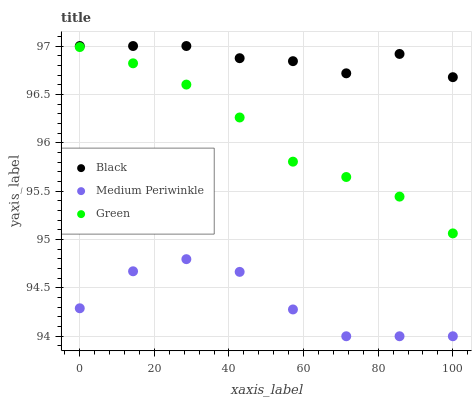Does Medium Periwinkle have the minimum area under the curve?
Answer yes or no. Yes. Does Black have the maximum area under the curve?
Answer yes or no. Yes. Does Green have the minimum area under the curve?
Answer yes or no. No. Does Green have the maximum area under the curve?
Answer yes or no. No. Is Green the smoothest?
Answer yes or no. Yes. Is Medium Periwinkle the roughest?
Answer yes or no. Yes. Is Black the smoothest?
Answer yes or no. No. Is Black the roughest?
Answer yes or no. No. Does Medium Periwinkle have the lowest value?
Answer yes or no. Yes. Does Green have the lowest value?
Answer yes or no. No. Does Black have the highest value?
Answer yes or no. Yes. Does Green have the highest value?
Answer yes or no. No. Is Medium Periwinkle less than Black?
Answer yes or no. Yes. Is Black greater than Medium Periwinkle?
Answer yes or no. Yes. Does Medium Periwinkle intersect Black?
Answer yes or no. No. 